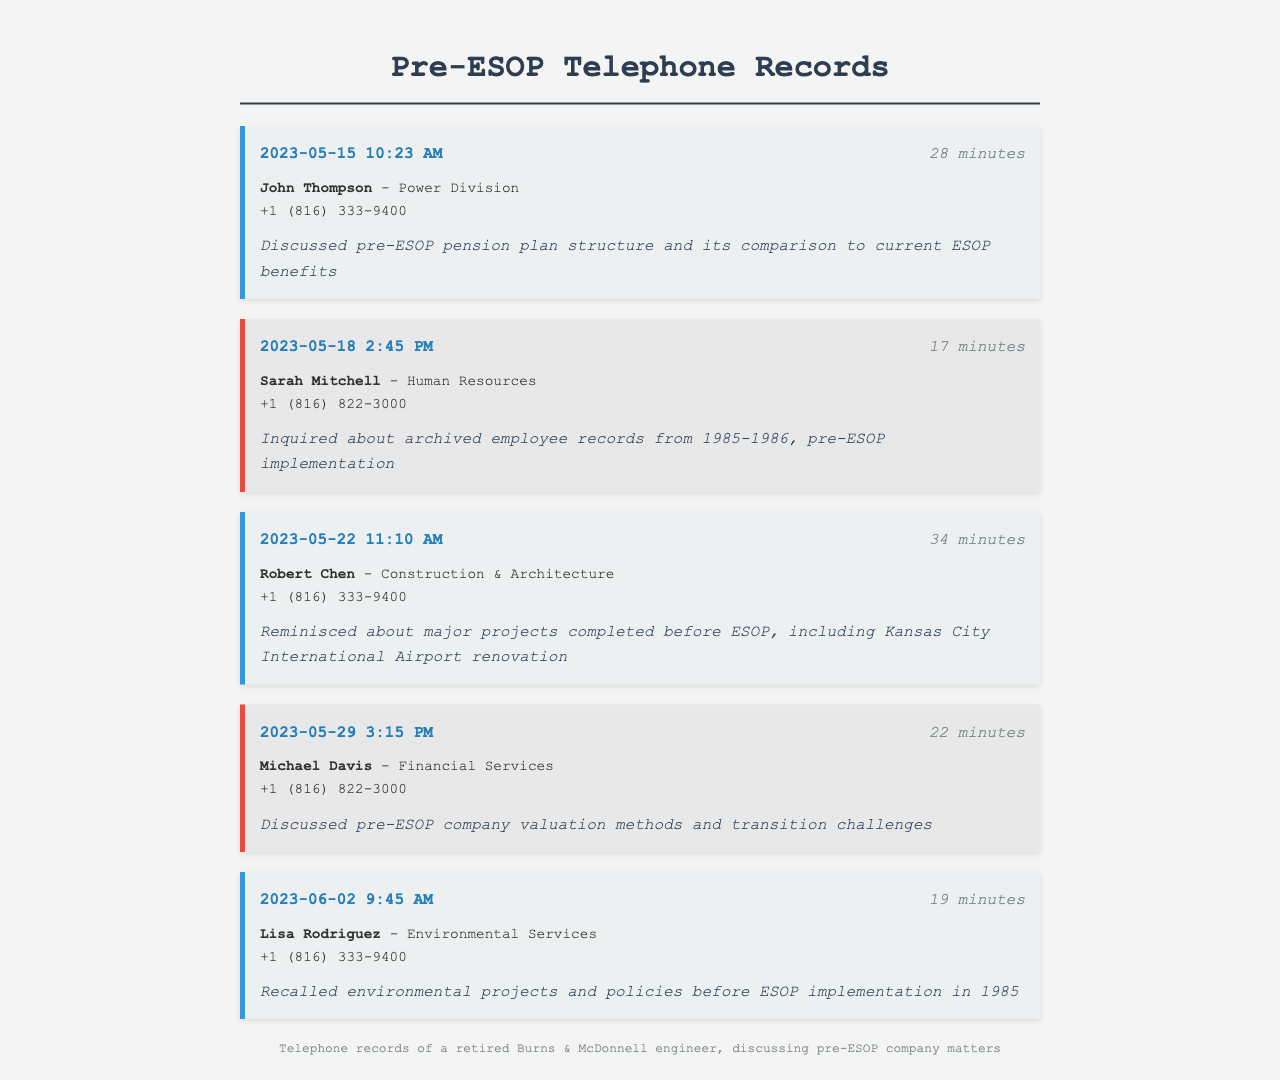what is the date of the call with John Thompson? The date is mentioned at the start of the record for John Thompson, which is 2023-05-15.
Answer: 2023-05-15 how long was the call with Sarah Mitchell? The duration of the call with Sarah Mitchell is stated clearly in her record, which is 17 minutes.
Answer: 17 minutes who did the engineer discuss pension plans with? The name of the colleague discussed with regarding pension plans is specified in the document as John Thompson.
Answer: John Thompson what department does Lisa Rodriguez work in? The department of Lisa Rodriguez is given in her contact information, which is Environmental Services.
Answer: Environmental Services which project was reminisced about during the call with Robert Chen? The project talked about during the call with Robert Chen is noted in the record, specifically the Kansas City International Airport renovation.
Answer: Kansas City International Airport renovation how many minutes did the call with Michael Davis last? The duration of Michael Davis's call is explicitly provided, lasting for 22 minutes.
Answer: 22 minutes what was the main topic of discussion in the call with Robert Chen? The discussion topic for Robert Chen is mentioned clearly in the record, which is major projects completed before ESOP.
Answer: major projects completed before ESOP who inquired about archived employee records? The document identifies Sarah Mitchell as the individual who made inquiries regarding archived records.
Answer: Sarah Mitchell what time was the call with Lisa Rodriguez? The time of the call with Lisa Rodriguez is indicated in her record, which is 9:45 AM.
Answer: 9:45 AM 